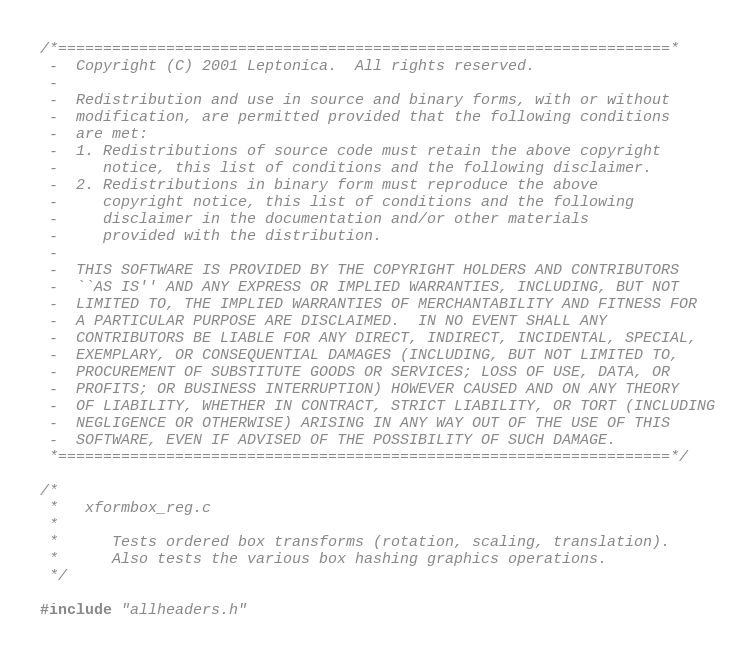<code> <loc_0><loc_0><loc_500><loc_500><_C_>/*====================================================================*
 -  Copyright (C) 2001 Leptonica.  All rights reserved.
 -
 -  Redistribution and use in source and binary forms, with or without
 -  modification, are permitted provided that the following conditions
 -  are met:
 -  1. Redistributions of source code must retain the above copyright
 -     notice, this list of conditions and the following disclaimer.
 -  2. Redistributions in binary form must reproduce the above
 -     copyright notice, this list of conditions and the following
 -     disclaimer in the documentation and/or other materials
 -     provided with the distribution.
 -
 -  THIS SOFTWARE IS PROVIDED BY THE COPYRIGHT HOLDERS AND CONTRIBUTORS
 -  ``AS IS'' AND ANY EXPRESS OR IMPLIED WARRANTIES, INCLUDING, BUT NOT
 -  LIMITED TO, THE IMPLIED WARRANTIES OF MERCHANTABILITY AND FITNESS FOR
 -  A PARTICULAR PURPOSE ARE DISCLAIMED.  IN NO EVENT SHALL ANY
 -  CONTRIBUTORS BE LIABLE FOR ANY DIRECT, INDIRECT, INCIDENTAL, SPECIAL,
 -  EXEMPLARY, OR CONSEQUENTIAL DAMAGES (INCLUDING, BUT NOT LIMITED TO,
 -  PROCUREMENT OF SUBSTITUTE GOODS OR SERVICES; LOSS OF USE, DATA, OR
 -  PROFITS; OR BUSINESS INTERRUPTION) HOWEVER CAUSED AND ON ANY THEORY
 -  OF LIABILITY, WHETHER IN CONTRACT, STRICT LIABILITY, OR TORT (INCLUDING
 -  NEGLIGENCE OR OTHERWISE) ARISING IN ANY WAY OUT OF THE USE OF THIS
 -  SOFTWARE, EVEN IF ADVISED OF THE POSSIBILITY OF SUCH DAMAGE.
 *====================================================================*/

/*
 *   xformbox_reg.c
 *
 *      Tests ordered box transforms (rotation, scaling, translation).
 *      Also tests the various box hashing graphics operations.
 */

#include "allheaders.h"
</code> 